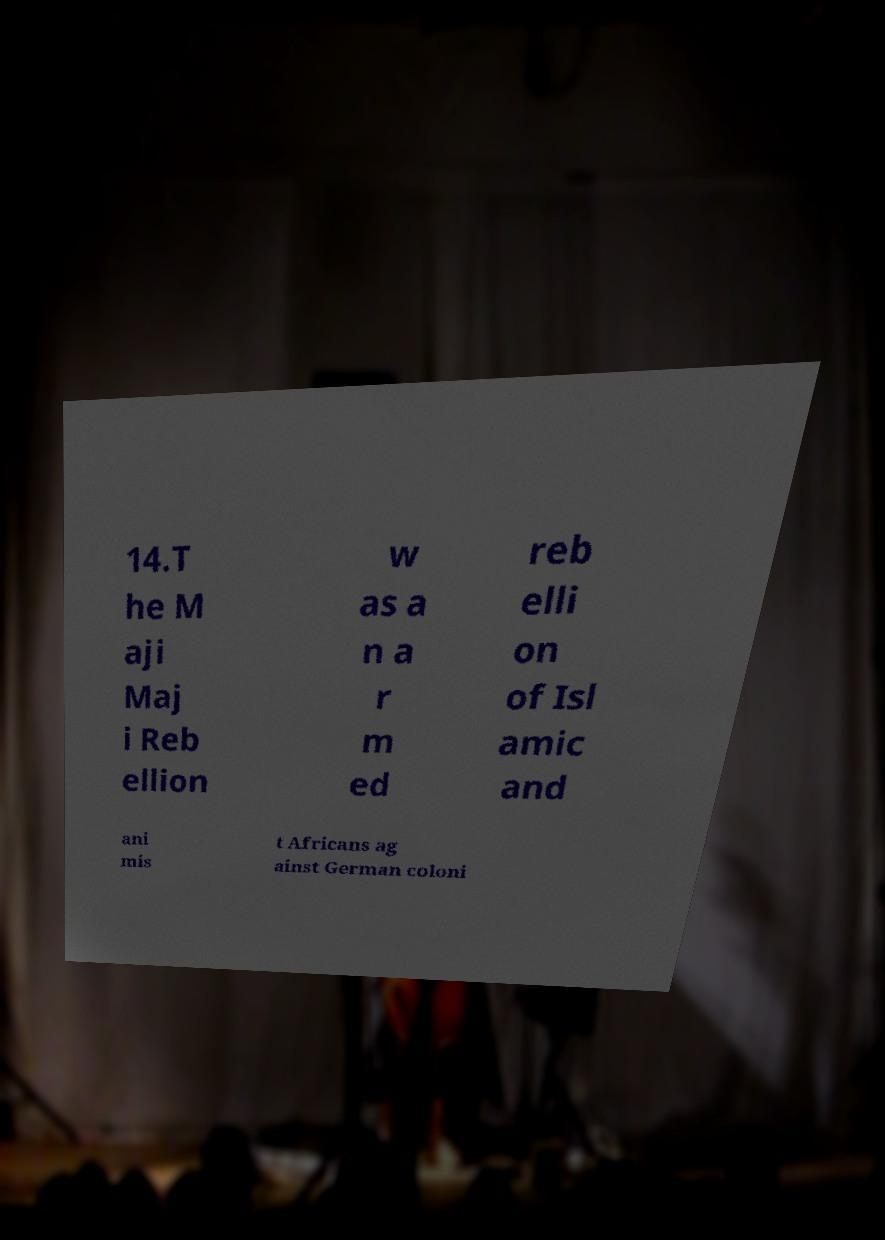For documentation purposes, I need the text within this image transcribed. Could you provide that? 14.T he M aji Maj i Reb ellion w as a n a r m ed reb elli on of Isl amic and ani mis t Africans ag ainst German coloni 